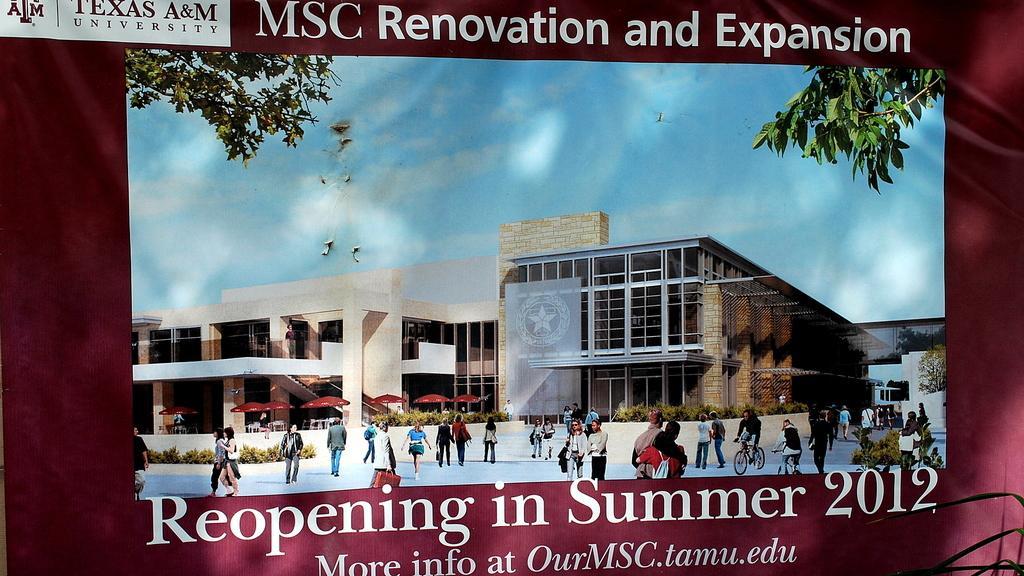Could you give a brief overview of what you see in this image? In the picture we can see a banner with an image of the building and some people walking near it and behind the building we can see the sky with clouds. 